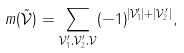<formula> <loc_0><loc_0><loc_500><loc_500>m ( \tilde { \mathcal { V } } ) = \sum _ { \mathcal { V } _ { 1 } ^ { \prime } , \mathcal { V } _ { 2 } ^ { \prime } , \mathcal { V } } ( - 1 ) ^ { | \mathcal { V } _ { 1 } ^ { \prime } | + | \mathcal { V } _ { 2 } ^ { \prime } | } ,</formula> 